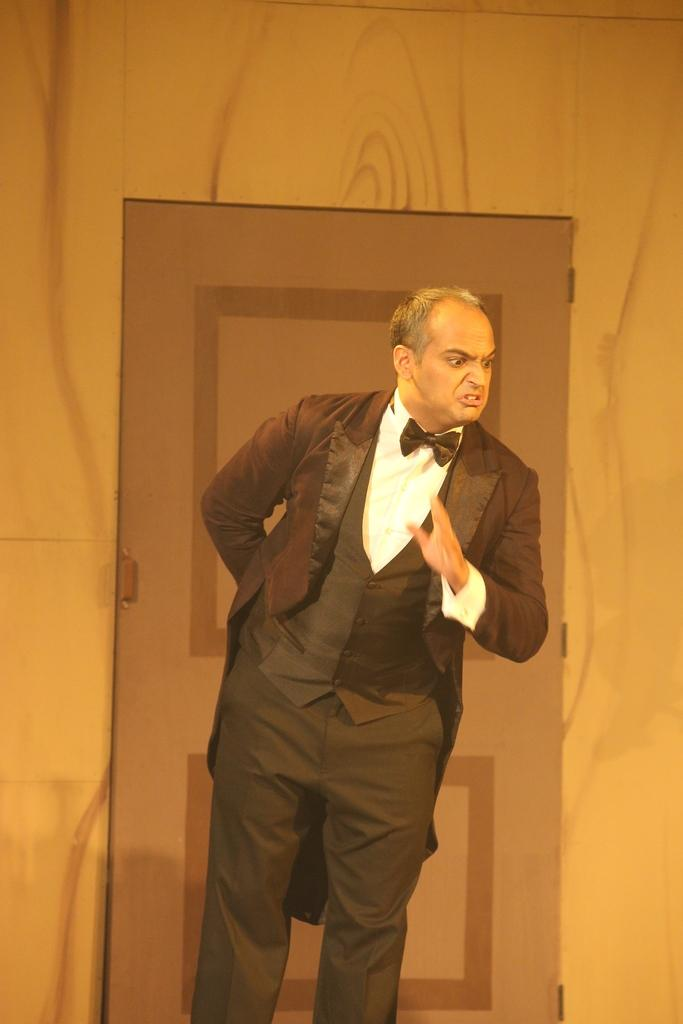Who is the main subject in the image? There is a man in the center of the image. What is the man wearing on his upper body? The man is wearing a blazer. What is the man wearing on his lower body? The man is wearing trousers. What type of neckwear is the man wearing? The man is wearing a bow tie. What can be seen in the background of the image? There is a wall with a door in the background of the image. How does the man roll in the image? The man is not rolling in the image; he is standing still. 